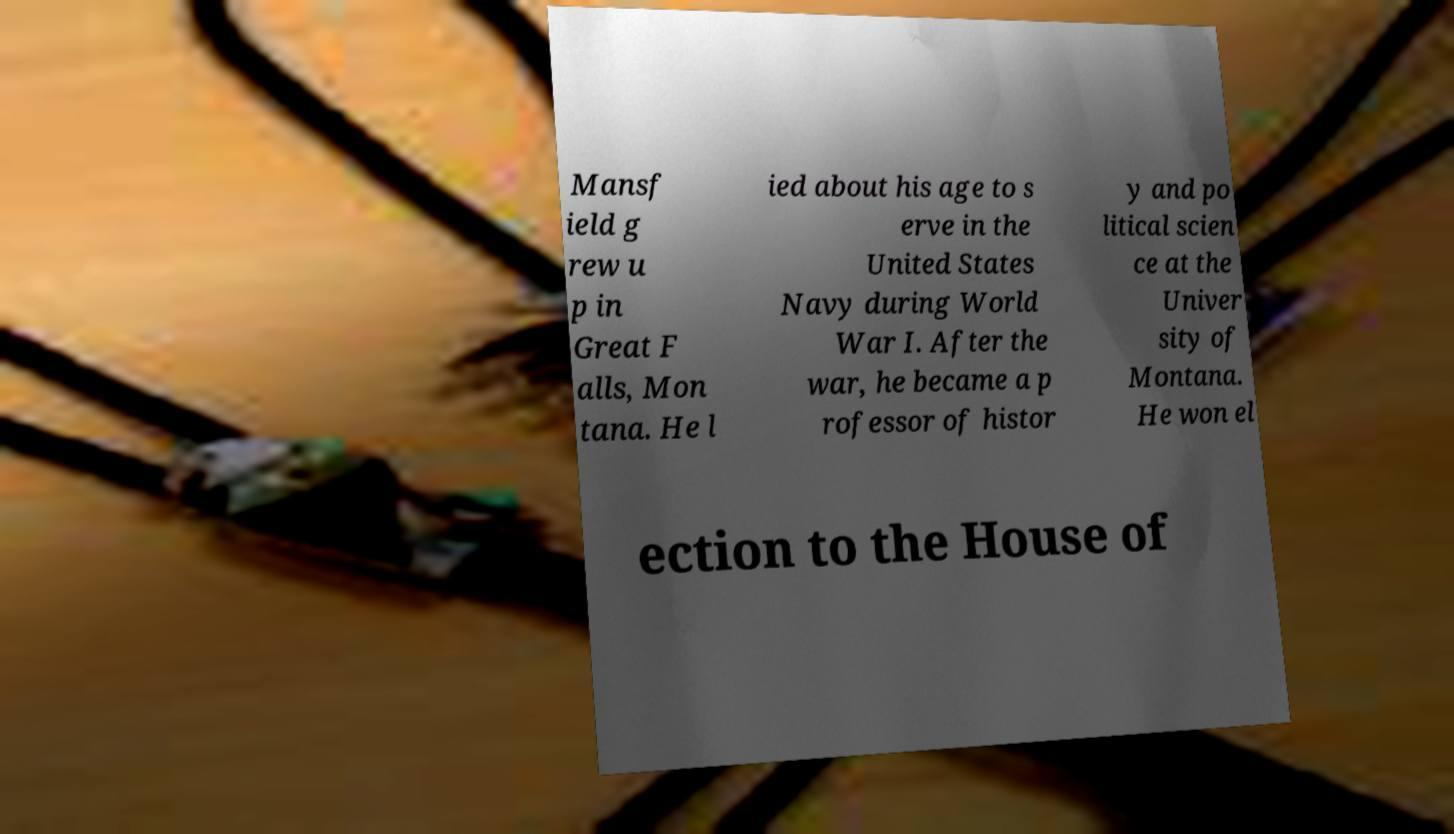Can you accurately transcribe the text from the provided image for me? Mansf ield g rew u p in Great F alls, Mon tana. He l ied about his age to s erve in the United States Navy during World War I. After the war, he became a p rofessor of histor y and po litical scien ce at the Univer sity of Montana. He won el ection to the House of 